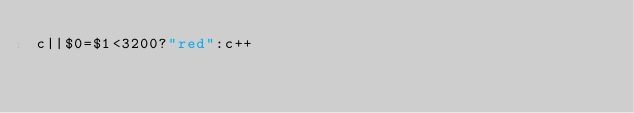<code> <loc_0><loc_0><loc_500><loc_500><_Awk_>c||$0=$1<3200?"red":c++</code> 